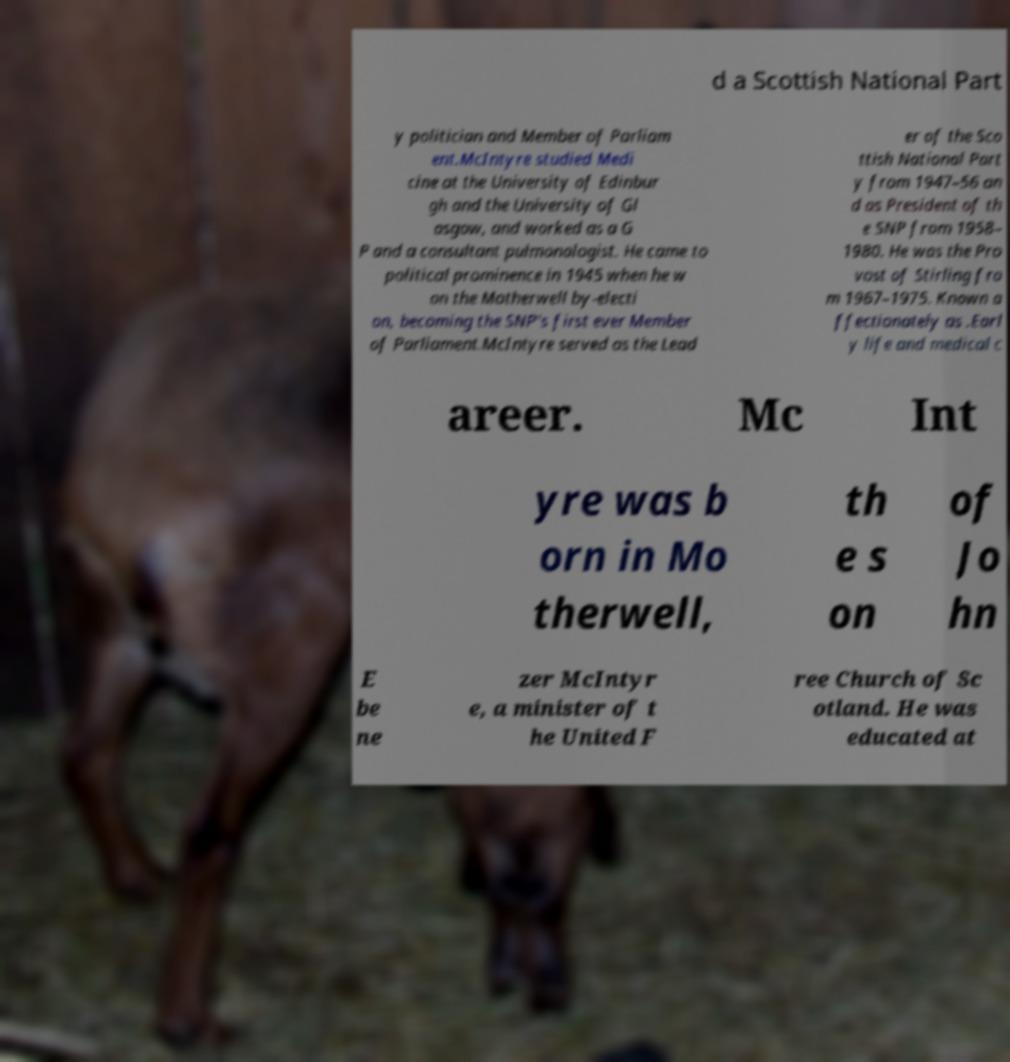Please identify and transcribe the text found in this image. d a Scottish National Part y politician and Member of Parliam ent.McIntyre studied Medi cine at the University of Edinbur gh and the University of Gl asgow, and worked as a G P and a consultant pulmonologist. He came to political prominence in 1945 when he w on the Motherwell by-electi on, becoming the SNP's first ever Member of Parliament.McIntyre served as the Lead er of the Sco ttish National Part y from 1947–56 an d as President of th e SNP from 1958– 1980. He was the Pro vost of Stirling fro m 1967–1975. Known a ffectionately as .Earl y life and medical c areer. Mc Int yre was b orn in Mo therwell, th e s on of Jo hn E be ne zer McIntyr e, a minister of t he United F ree Church of Sc otland. He was educated at 